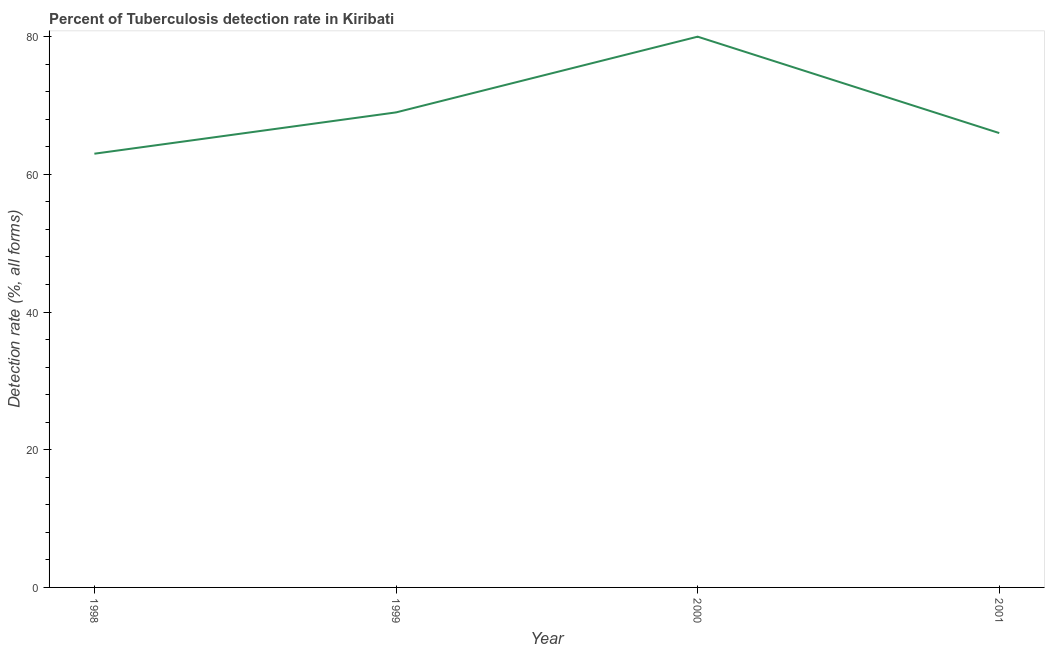What is the detection rate of tuberculosis in 1999?
Provide a succinct answer. 69. Across all years, what is the maximum detection rate of tuberculosis?
Make the answer very short. 80. Across all years, what is the minimum detection rate of tuberculosis?
Your answer should be compact. 63. In which year was the detection rate of tuberculosis maximum?
Your response must be concise. 2000. What is the sum of the detection rate of tuberculosis?
Ensure brevity in your answer.  278. What is the difference between the detection rate of tuberculosis in 1998 and 1999?
Offer a terse response. -6. What is the average detection rate of tuberculosis per year?
Your answer should be very brief. 69.5. What is the median detection rate of tuberculosis?
Provide a short and direct response. 67.5. What is the ratio of the detection rate of tuberculosis in 1998 to that in 2000?
Provide a short and direct response. 0.79. Is the detection rate of tuberculosis in 1998 less than that in 2000?
Offer a very short reply. Yes. What is the difference between the highest and the second highest detection rate of tuberculosis?
Provide a succinct answer. 11. What is the difference between the highest and the lowest detection rate of tuberculosis?
Your answer should be very brief. 17. Does the detection rate of tuberculosis monotonically increase over the years?
Offer a terse response. No. How many lines are there?
Ensure brevity in your answer.  1. How many years are there in the graph?
Give a very brief answer. 4. What is the difference between two consecutive major ticks on the Y-axis?
Give a very brief answer. 20. Does the graph contain any zero values?
Offer a terse response. No. Does the graph contain grids?
Your response must be concise. No. What is the title of the graph?
Give a very brief answer. Percent of Tuberculosis detection rate in Kiribati. What is the label or title of the Y-axis?
Your answer should be compact. Detection rate (%, all forms). What is the Detection rate (%, all forms) of 2000?
Provide a short and direct response. 80. What is the difference between the Detection rate (%, all forms) in 1998 and 2000?
Offer a terse response. -17. What is the difference between the Detection rate (%, all forms) in 1998 and 2001?
Ensure brevity in your answer.  -3. What is the difference between the Detection rate (%, all forms) in 1999 and 2000?
Keep it short and to the point. -11. What is the ratio of the Detection rate (%, all forms) in 1998 to that in 2000?
Provide a short and direct response. 0.79. What is the ratio of the Detection rate (%, all forms) in 1998 to that in 2001?
Your answer should be compact. 0.95. What is the ratio of the Detection rate (%, all forms) in 1999 to that in 2000?
Give a very brief answer. 0.86. What is the ratio of the Detection rate (%, all forms) in 1999 to that in 2001?
Ensure brevity in your answer.  1.04. What is the ratio of the Detection rate (%, all forms) in 2000 to that in 2001?
Your response must be concise. 1.21. 